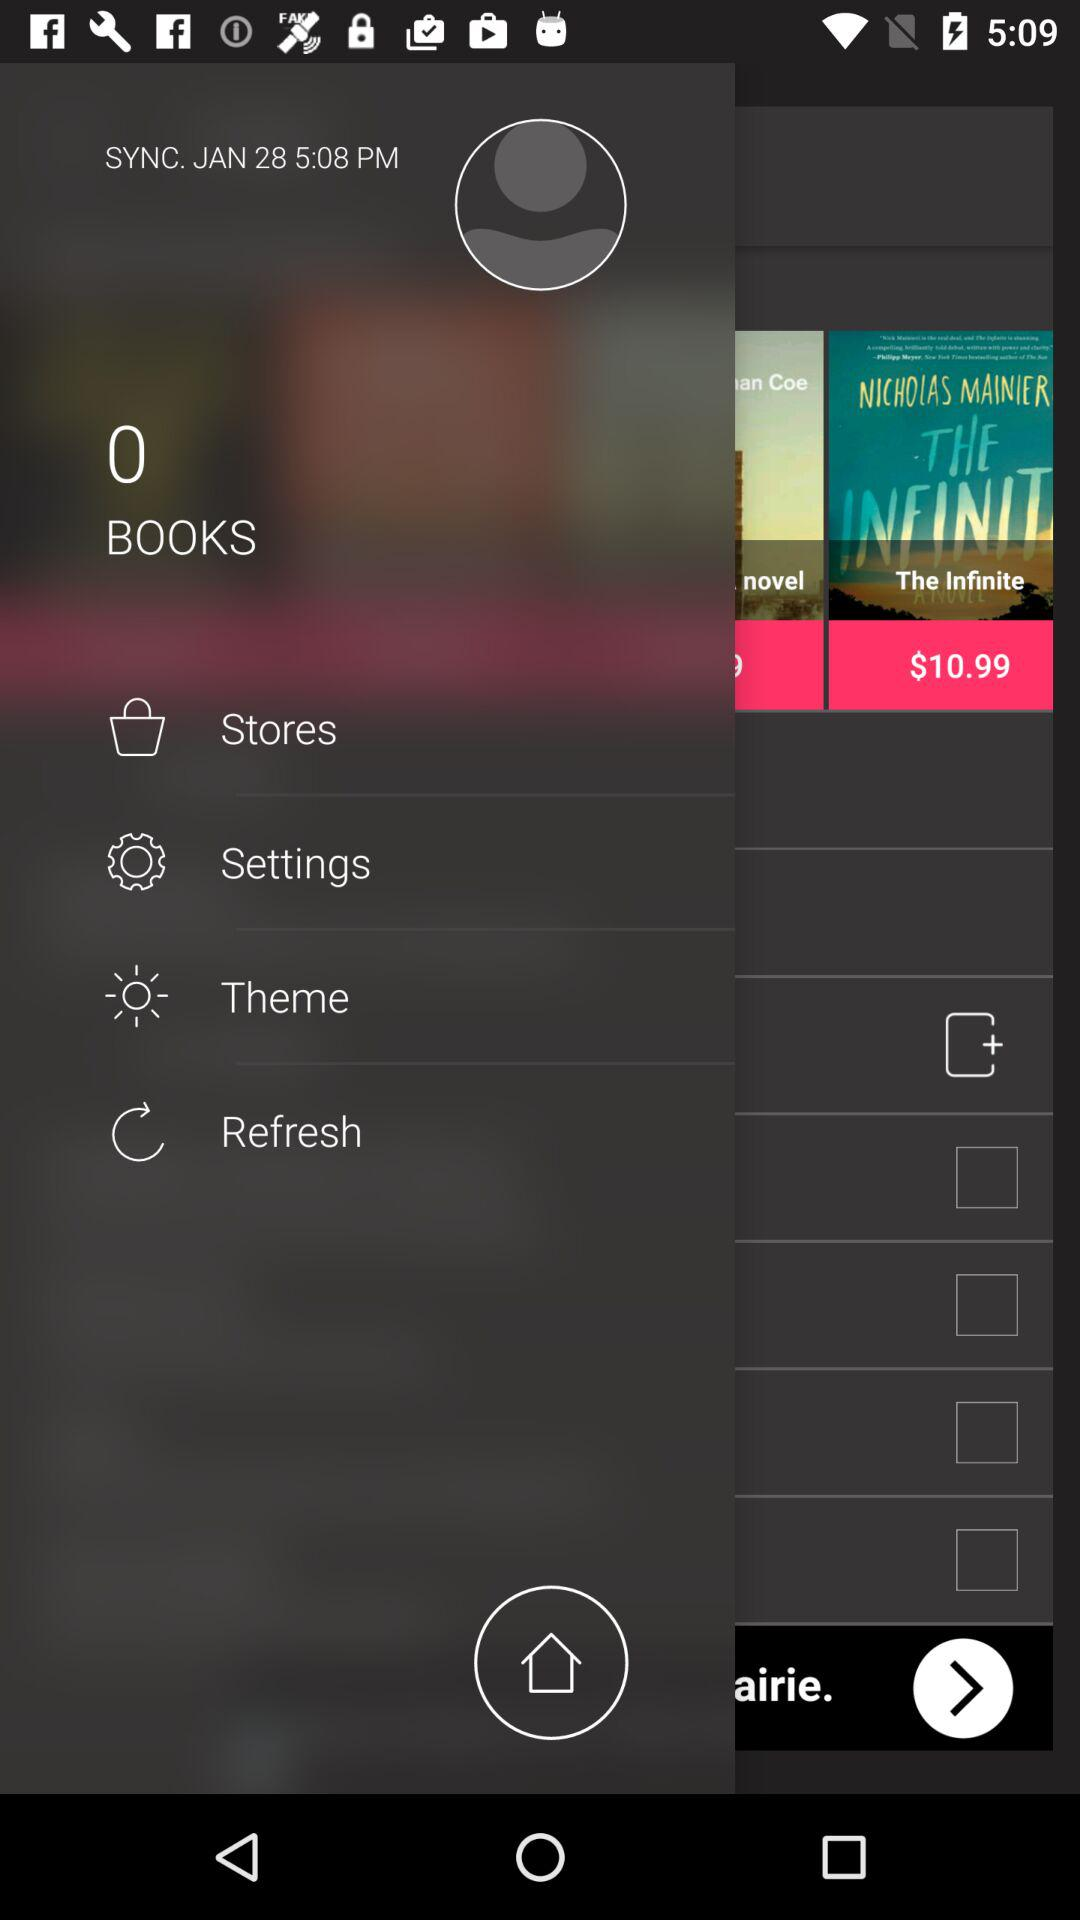When was the last time the application was synchronized? The application was last synchronized at 5:08 p.m. 